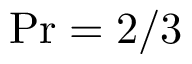Convert formula to latex. <formula><loc_0><loc_0><loc_500><loc_500>P r = { 2 } / { 3 }</formula> 